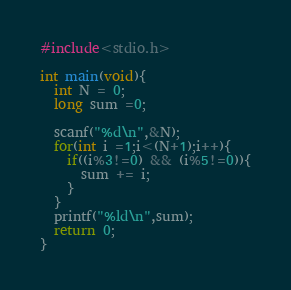Convert code to text. <code><loc_0><loc_0><loc_500><loc_500><_C_>#include<stdio.h>

int main(void){
  int N = 0;
  long sum =0;

  scanf("%d\n",&N);
  for(int i =1;i<(N+1);i++){
    if((i%3!=0) && (i%5!=0)){
      sum += i;
    }
  }
  printf("%ld\n",sum);
  return 0;
}</code> 